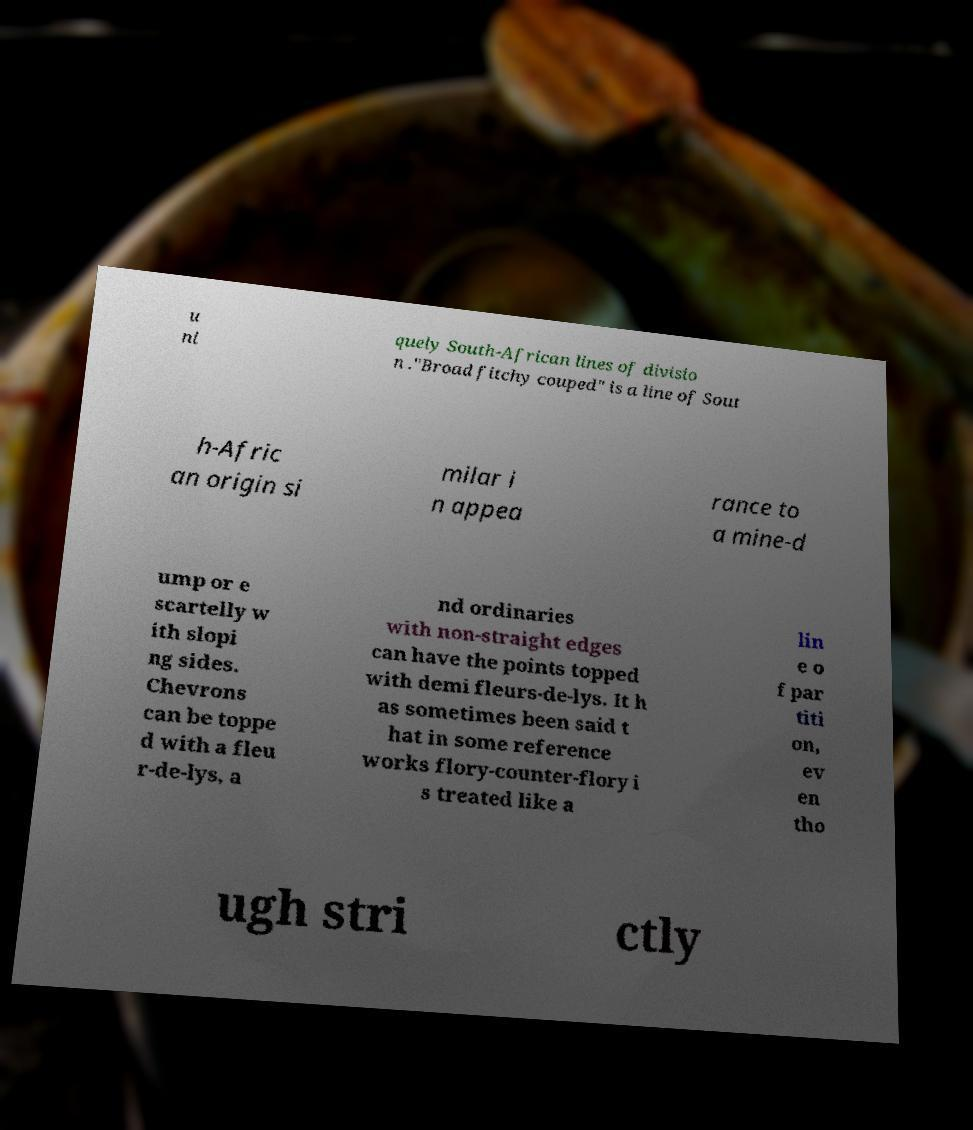Can you read and provide the text displayed in the image?This photo seems to have some interesting text. Can you extract and type it out for me? u ni quely South-African lines of divisio n ."Broad fitchy couped" is a line of Sout h-Afric an origin si milar i n appea rance to a mine-d ump or e scartelly w ith slopi ng sides. Chevrons can be toppe d with a fleu r-de-lys, a nd ordinaries with non-straight edges can have the points topped with demi fleurs-de-lys. It h as sometimes been said t hat in some reference works flory-counter-flory i s treated like a lin e o f par titi on, ev en tho ugh stri ctly 